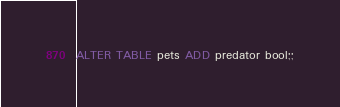<code> <loc_0><loc_0><loc_500><loc_500><_SQL_>ALTER TABLE pets ADD predator bool;;</code> 